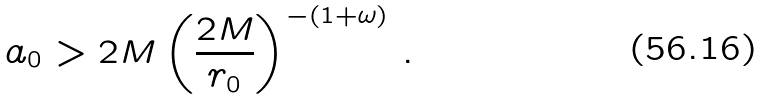<formula> <loc_0><loc_0><loc_500><loc_500>a _ { 0 } > 2 M \left ( \frac { 2 M } { r _ { 0 } } \right ) ^ { - ( 1 + \omega ) } \, .</formula> 